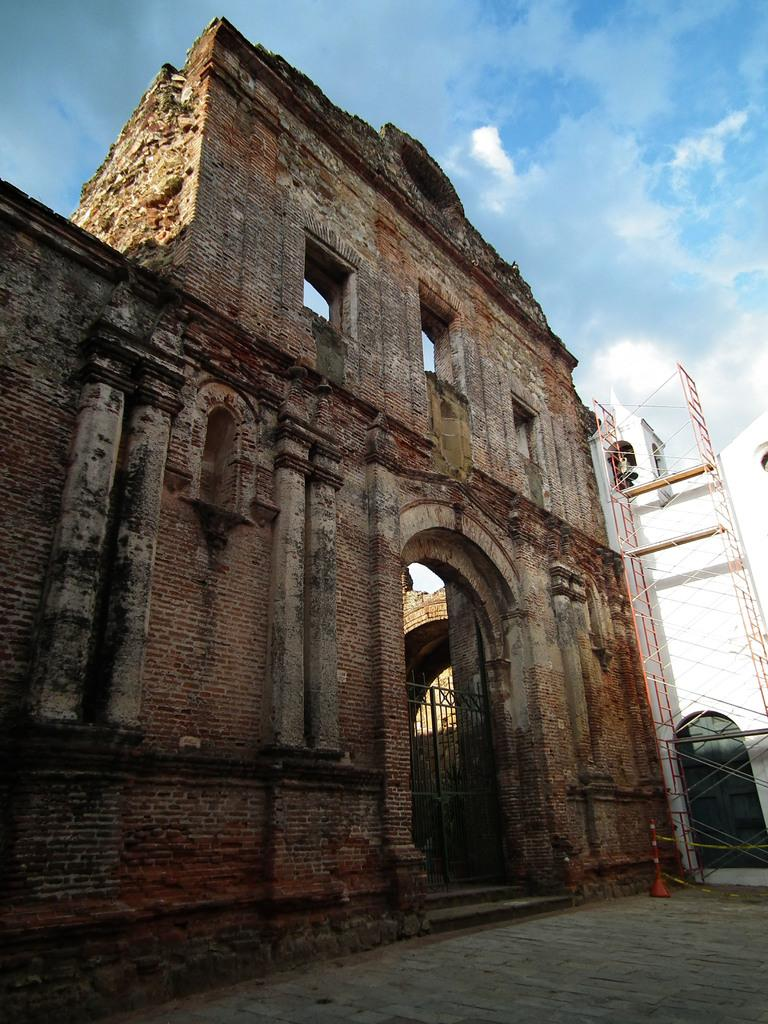What type of building is in the image? There is a stone building in the image. What is the entrance to the building like? There is a gate in the image. What can be found near the gate? There is a stand in the image. What is the color of the other building in the image? There is a white color building in the image. What can be seen in the sky in the background of the image? The sky is blue in the background of the image, and there are clouds in the sky. What type of silk is being sold at the stand in the image? There is no mention of silk or any apparel being sold at the stand in the image. Can you see a kite flying in the sky in the background of the image? There is no kite visible in the sky in the background of the image. 